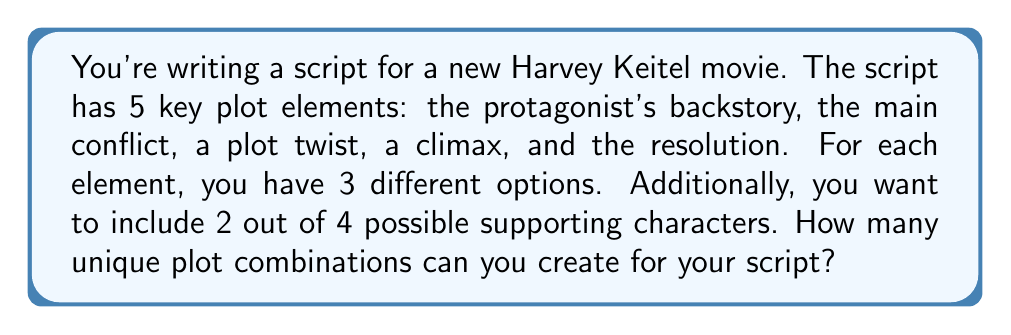Give your solution to this math problem. Let's break this down step-by-step:

1. First, let's consider the 5 key plot elements:
   - Each element has 3 options
   - We need to choose one option for each element
   - This is a multiplication principle problem

   Number of combinations for plot elements = $3 \times 3 \times 3 \times 3 \times 3 = 3^5 = 243$

2. Now, for the supporting characters:
   - We have 4 characters to choose from
   - We need to select 2 of them
   - This is a combination problem

   Number of ways to choose supporting characters = $\binom{4}{2} = \frac{4!}{2!(4-2)!} = \frac{4 \times 3}{2 \times 1} = 6$

3. To get the total number of unique plot combinations, we multiply the results from steps 1 and 2:

   Total combinations = (Plot element combinations) $\times$ (Supporting character combinations)
   
   $$ 243 \times 6 = 1,458 $$

Therefore, you can create 1,458 unique plot combinations for your Harvey Keitel movie script.
Answer: 1,458 unique plot combinations 